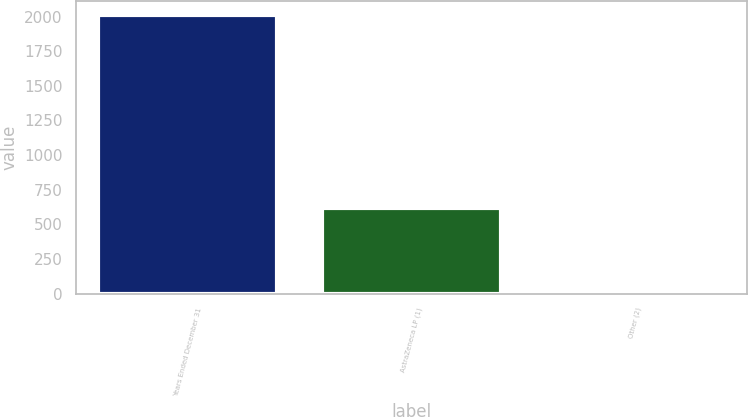Convert chart. <chart><loc_0><loc_0><loc_500><loc_500><bar_chart><fcel>Years Ended December 31<fcel>AstraZeneca LP (1)<fcel>Other (2)<nl><fcel>2012<fcel>621<fcel>21<nl></chart> 